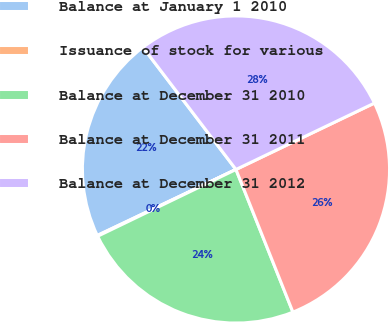Convert chart. <chart><loc_0><loc_0><loc_500><loc_500><pie_chart><fcel>Balance at January 1 2010<fcel>Issuance of stock for various<fcel>Balance at December 31 2010<fcel>Balance at December 31 2011<fcel>Balance at December 31 2012<nl><fcel>21.71%<fcel>0.09%<fcel>23.89%<fcel>26.07%<fcel>28.24%<nl></chart> 